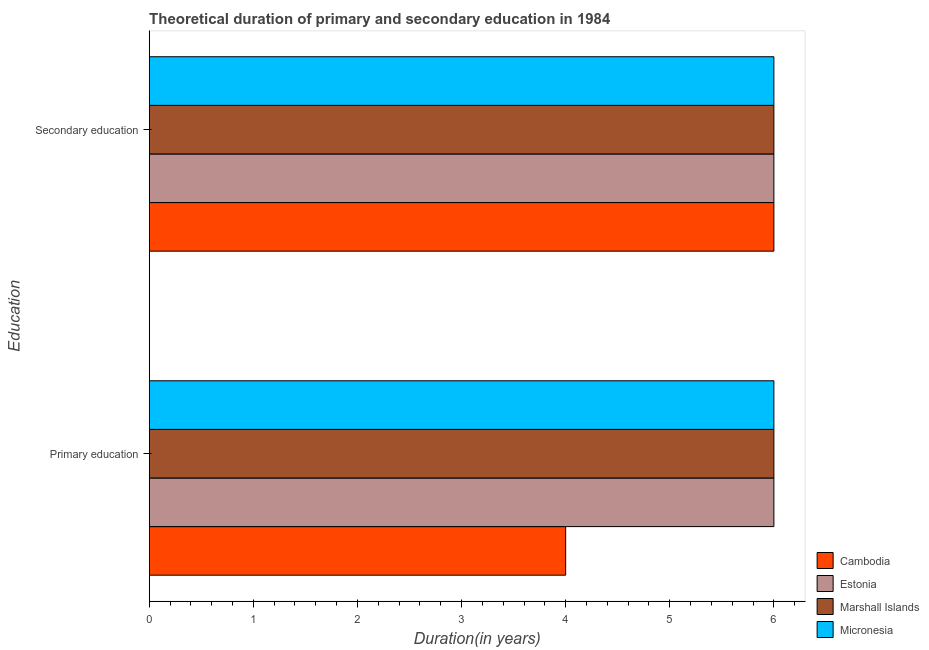How many different coloured bars are there?
Give a very brief answer. 4. How many groups of bars are there?
Keep it short and to the point. 2. How many bars are there on the 1st tick from the top?
Your answer should be compact. 4. How many bars are there on the 1st tick from the bottom?
Your response must be concise. 4. What is the label of the 2nd group of bars from the top?
Give a very brief answer. Primary education. What is the duration of secondary education in Marshall Islands?
Your answer should be very brief. 6. Across all countries, what is the maximum duration of primary education?
Offer a very short reply. 6. Across all countries, what is the minimum duration of primary education?
Make the answer very short. 4. In which country was the duration of secondary education maximum?
Ensure brevity in your answer.  Cambodia. In which country was the duration of primary education minimum?
Provide a succinct answer. Cambodia. What is the total duration of primary education in the graph?
Your answer should be compact. 22. What is the difference between the duration of secondary education in Marshall Islands and that in Micronesia?
Keep it short and to the point. 0. What is the difference between the duration of primary education in Estonia and the duration of secondary education in Micronesia?
Provide a short and direct response. 0. What is the average duration of primary education per country?
Make the answer very short. 5.5. In how many countries, is the duration of secondary education greater than 5.6 years?
Provide a short and direct response. 4. What is the ratio of the duration of secondary education in Estonia to that in Cambodia?
Your response must be concise. 1. In how many countries, is the duration of primary education greater than the average duration of primary education taken over all countries?
Make the answer very short. 3. What does the 1st bar from the top in Secondary education represents?
Your response must be concise. Micronesia. What does the 3rd bar from the bottom in Primary education represents?
Keep it short and to the point. Marshall Islands. How many countries are there in the graph?
Give a very brief answer. 4. What is the difference between two consecutive major ticks on the X-axis?
Your answer should be compact. 1. Are the values on the major ticks of X-axis written in scientific E-notation?
Keep it short and to the point. No. Does the graph contain any zero values?
Offer a terse response. No. Where does the legend appear in the graph?
Your response must be concise. Bottom right. How many legend labels are there?
Your answer should be very brief. 4. What is the title of the graph?
Your answer should be very brief. Theoretical duration of primary and secondary education in 1984. What is the label or title of the X-axis?
Your answer should be compact. Duration(in years). What is the label or title of the Y-axis?
Keep it short and to the point. Education. What is the Duration(in years) of Estonia in Primary education?
Make the answer very short. 6. What is the Duration(in years) of Marshall Islands in Primary education?
Make the answer very short. 6. What is the Duration(in years) of Micronesia in Primary education?
Provide a succinct answer. 6. What is the Duration(in years) of Cambodia in Secondary education?
Provide a short and direct response. 6. What is the Duration(in years) in Estonia in Secondary education?
Offer a very short reply. 6. What is the Duration(in years) in Marshall Islands in Secondary education?
Your response must be concise. 6. Across all Education, what is the maximum Duration(in years) of Estonia?
Provide a succinct answer. 6. Across all Education, what is the maximum Duration(in years) in Marshall Islands?
Offer a very short reply. 6. Across all Education, what is the maximum Duration(in years) in Micronesia?
Provide a short and direct response. 6. Across all Education, what is the minimum Duration(in years) of Cambodia?
Give a very brief answer. 4. Across all Education, what is the minimum Duration(in years) of Marshall Islands?
Provide a succinct answer. 6. Across all Education, what is the minimum Duration(in years) of Micronesia?
Provide a succinct answer. 6. What is the total Duration(in years) in Cambodia in the graph?
Keep it short and to the point. 10. What is the total Duration(in years) in Estonia in the graph?
Your response must be concise. 12. What is the total Duration(in years) of Micronesia in the graph?
Give a very brief answer. 12. What is the difference between the Duration(in years) of Marshall Islands in Primary education and that in Secondary education?
Provide a succinct answer. 0. What is the difference between the Duration(in years) in Micronesia in Primary education and that in Secondary education?
Your answer should be compact. 0. What is the difference between the Duration(in years) in Cambodia in Primary education and the Duration(in years) in Marshall Islands in Secondary education?
Your answer should be very brief. -2. What is the difference between the Duration(in years) in Estonia in Primary education and the Duration(in years) in Marshall Islands in Secondary education?
Offer a terse response. 0. What is the difference between the Duration(in years) of Estonia in Primary education and the Duration(in years) of Micronesia in Secondary education?
Your answer should be very brief. 0. What is the difference between the Duration(in years) of Marshall Islands in Primary education and the Duration(in years) of Micronesia in Secondary education?
Provide a succinct answer. 0. What is the average Duration(in years) of Cambodia per Education?
Give a very brief answer. 5. What is the difference between the Duration(in years) of Cambodia and Duration(in years) of Estonia in Primary education?
Give a very brief answer. -2. What is the difference between the Duration(in years) in Cambodia and Duration(in years) in Marshall Islands in Primary education?
Your answer should be very brief. -2. What is the difference between the Duration(in years) of Marshall Islands and Duration(in years) of Micronesia in Primary education?
Make the answer very short. 0. What is the difference between the Duration(in years) of Cambodia and Duration(in years) of Estonia in Secondary education?
Your answer should be compact. 0. What is the difference between the Duration(in years) in Marshall Islands and Duration(in years) in Micronesia in Secondary education?
Provide a short and direct response. 0. What is the ratio of the Duration(in years) of Cambodia in Primary education to that in Secondary education?
Your response must be concise. 0.67. What is the ratio of the Duration(in years) of Estonia in Primary education to that in Secondary education?
Provide a succinct answer. 1. What is the ratio of the Duration(in years) in Marshall Islands in Primary education to that in Secondary education?
Your answer should be very brief. 1. What is the difference between the highest and the second highest Duration(in years) in Estonia?
Ensure brevity in your answer.  0. What is the difference between the highest and the second highest Duration(in years) in Micronesia?
Ensure brevity in your answer.  0. 